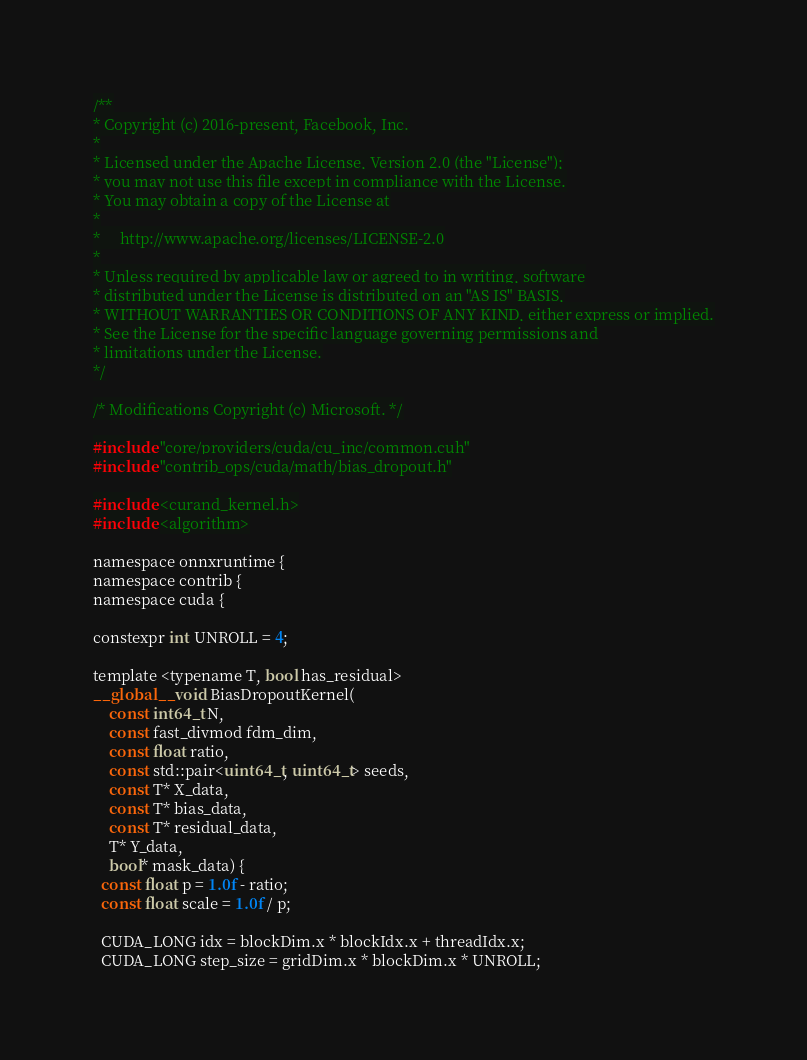<code> <loc_0><loc_0><loc_500><loc_500><_Cuda_>/**
* Copyright (c) 2016-present, Facebook, Inc.
*
* Licensed under the Apache License, Version 2.0 (the "License");
* you may not use this file except in compliance with the License.
* You may obtain a copy of the License at
*
*     http://www.apache.org/licenses/LICENSE-2.0
*
* Unless required by applicable law or agreed to in writing, software
* distributed under the License is distributed on an "AS IS" BASIS,
* WITHOUT WARRANTIES OR CONDITIONS OF ANY KIND, either express or implied.
* See the License for the specific language governing permissions and
* limitations under the License.
*/

/* Modifications Copyright (c) Microsoft. */

#include "core/providers/cuda/cu_inc/common.cuh"
#include "contrib_ops/cuda/math/bias_dropout.h"

#include <curand_kernel.h>
#include <algorithm>

namespace onnxruntime {
namespace contrib {
namespace cuda {

constexpr int UNROLL = 4;

template <typename T, bool has_residual>
__global__ void BiasDropoutKernel(
    const int64_t N,
    const fast_divmod fdm_dim,
    const float ratio,
    const std::pair<uint64_t, uint64_t> seeds,
    const T* X_data,
    const T* bias_data,
    const T* residual_data,
    T* Y_data,
    bool* mask_data) {
  const float p = 1.0f - ratio;
  const float scale = 1.0f / p;

  CUDA_LONG idx = blockDim.x * blockIdx.x + threadIdx.x;
  CUDA_LONG step_size = gridDim.x * blockDim.x * UNROLL;</code> 